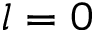Convert formula to latex. <formula><loc_0><loc_0><loc_500><loc_500>l = 0</formula> 